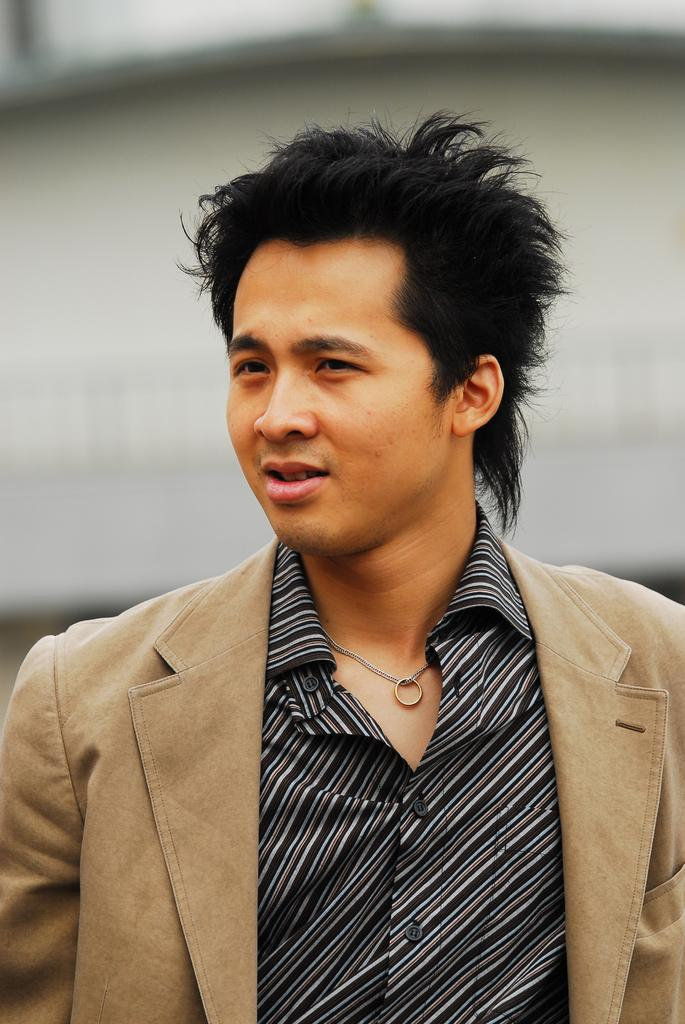Who is present in the image? There is a man in the image. What is the man wearing in the image? The man is wearing a chain with a ring. Can you describe the background of the image? The background of the image is blurred. How many frogs can be seen hopping around in the image? There are no frogs present in the image. What type of drink is the man holding in the image? There is no drink visible in the image. 